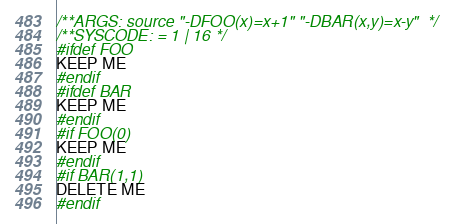<code> <loc_0><loc_0><loc_500><loc_500><_C_>/**ARGS: source "-DFOO(x)=x+1" "-DBAR(x,y)=x-y"  */
/**SYSCODE: = 1 | 16 */
#ifdef FOO
KEEP ME
#endif
#ifdef BAR
KEEP ME
#endif
#if FOO(0)
KEEP ME
#endif
#if BAR(1,1)
DELETE ME
#endif

</code> 